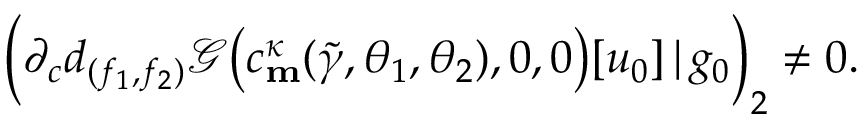<formula> <loc_0><loc_0><loc_500><loc_500>\left ( \partial _ { c } d _ { ( f _ { 1 } , f _ { 2 } ) } \ m a t h s c r { G } \left ( c _ { m } ^ { \kappa } ( \widetilde { \gamma } , \theta _ { 1 } , \theta _ { 2 } ) , 0 , 0 \right ) [ u _ { 0 } ] \, | \, g _ { 0 } \right ) _ { 2 } \neq 0 .</formula> 